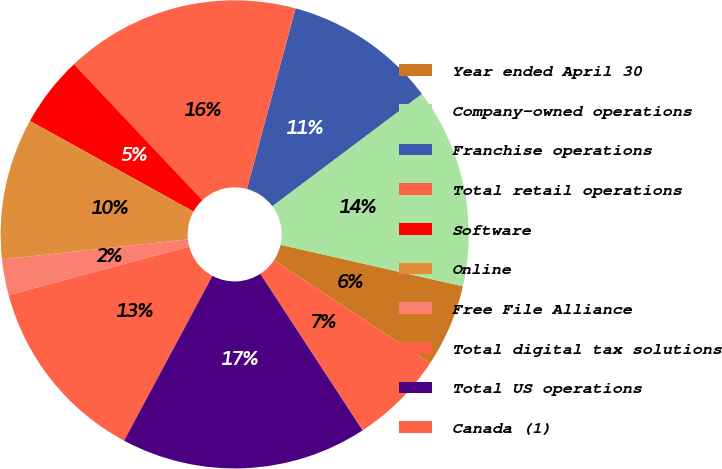Convert chart. <chart><loc_0><loc_0><loc_500><loc_500><pie_chart><fcel>Year ended April 30<fcel>Company-owned operations<fcel>Franchise operations<fcel>Total retail operations<fcel>Software<fcel>Online<fcel>Free File Alliance<fcel>Total digital tax solutions<fcel>Total US operations<fcel>Canada (1)<nl><fcel>5.71%<fcel>13.81%<fcel>10.57%<fcel>16.24%<fcel>4.9%<fcel>9.76%<fcel>2.47%<fcel>13.0%<fcel>17.05%<fcel>6.52%<nl></chart> 